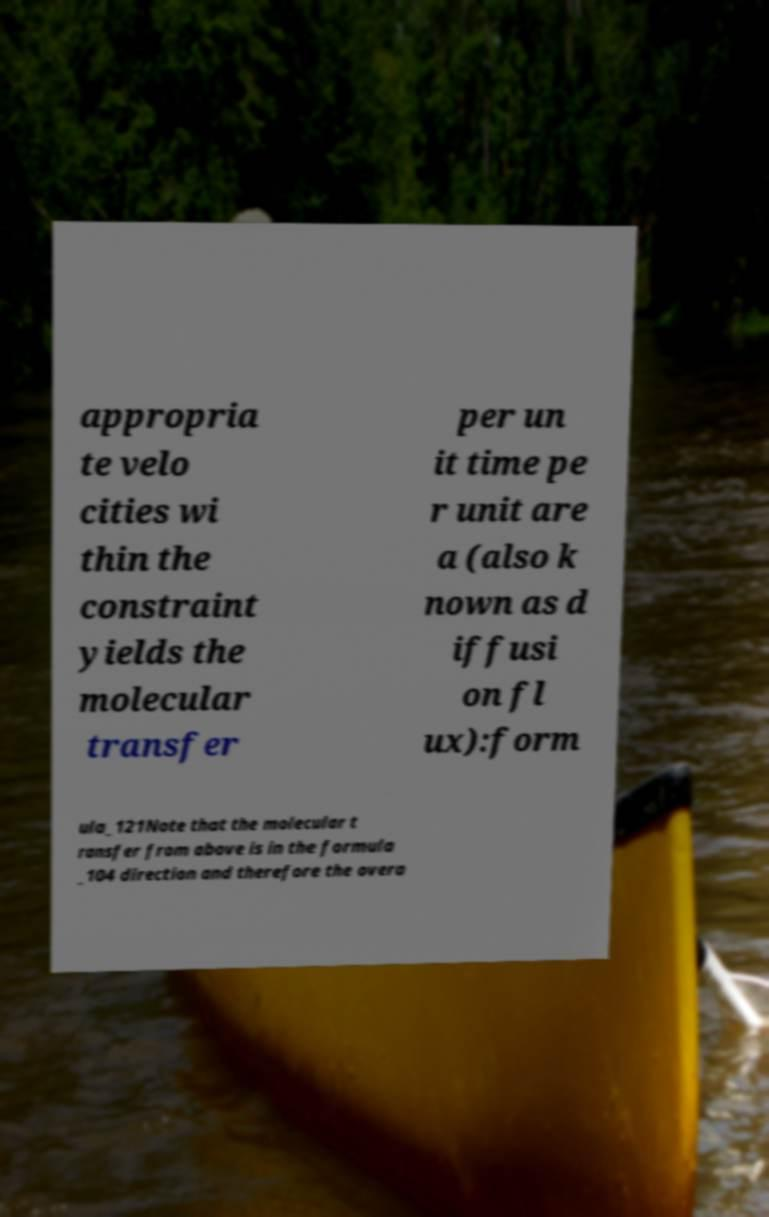For documentation purposes, I need the text within this image transcribed. Could you provide that? appropria te velo cities wi thin the constraint yields the molecular transfer per un it time pe r unit are a (also k nown as d iffusi on fl ux):form ula_121Note that the molecular t ransfer from above is in the formula _104 direction and therefore the overa 